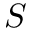Convert formula to latex. <formula><loc_0><loc_0><loc_500><loc_500>S</formula> 